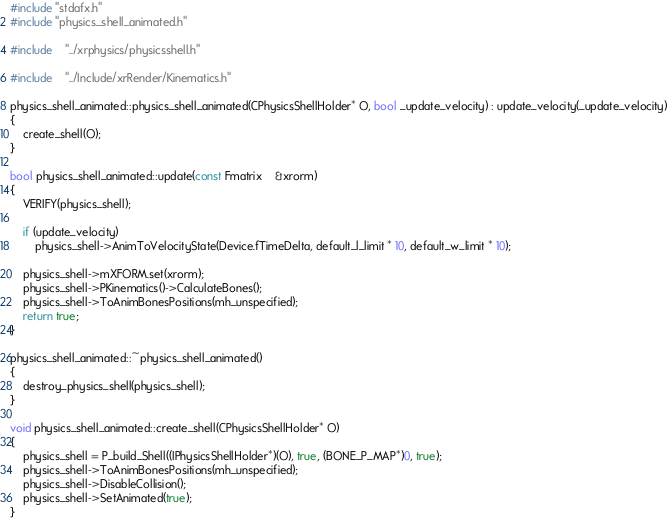<code> <loc_0><loc_0><loc_500><loc_500><_C++_>#include "stdafx.h"
#include "physics_shell_animated.h"

#include	"../xrphysics/physicsshell.h"

#include	"../Include/xrRender/Kinematics.h"

physics_shell_animated::physics_shell_animated(CPhysicsShellHolder* O, bool _update_velocity) : update_velocity(_update_velocity)
{
	create_shell(O);
}

bool physics_shell_animated::update(const Fmatrix	&xrorm)
{
	VERIFY(physics_shell);

	if (update_velocity)
		physics_shell->AnimToVelocityState(Device.fTimeDelta, default_l_limit * 10, default_w_limit * 10);

	physics_shell->mXFORM.set(xrorm);
	physics_shell->PKinematics()->CalculateBones();
	physics_shell->ToAnimBonesPositions(mh_unspecified);
	return true;
}

physics_shell_animated::~physics_shell_animated()
{
	destroy_physics_shell(physics_shell);
}

void physics_shell_animated::create_shell(CPhysicsShellHolder* O)
{
	physics_shell = P_build_Shell((IPhysicsShellHolder*)(O), true, (BONE_P_MAP*)0, true);
	physics_shell->ToAnimBonesPositions(mh_unspecified);
	physics_shell->DisableCollision();
	physics_shell->SetAnimated(true);
}</code> 